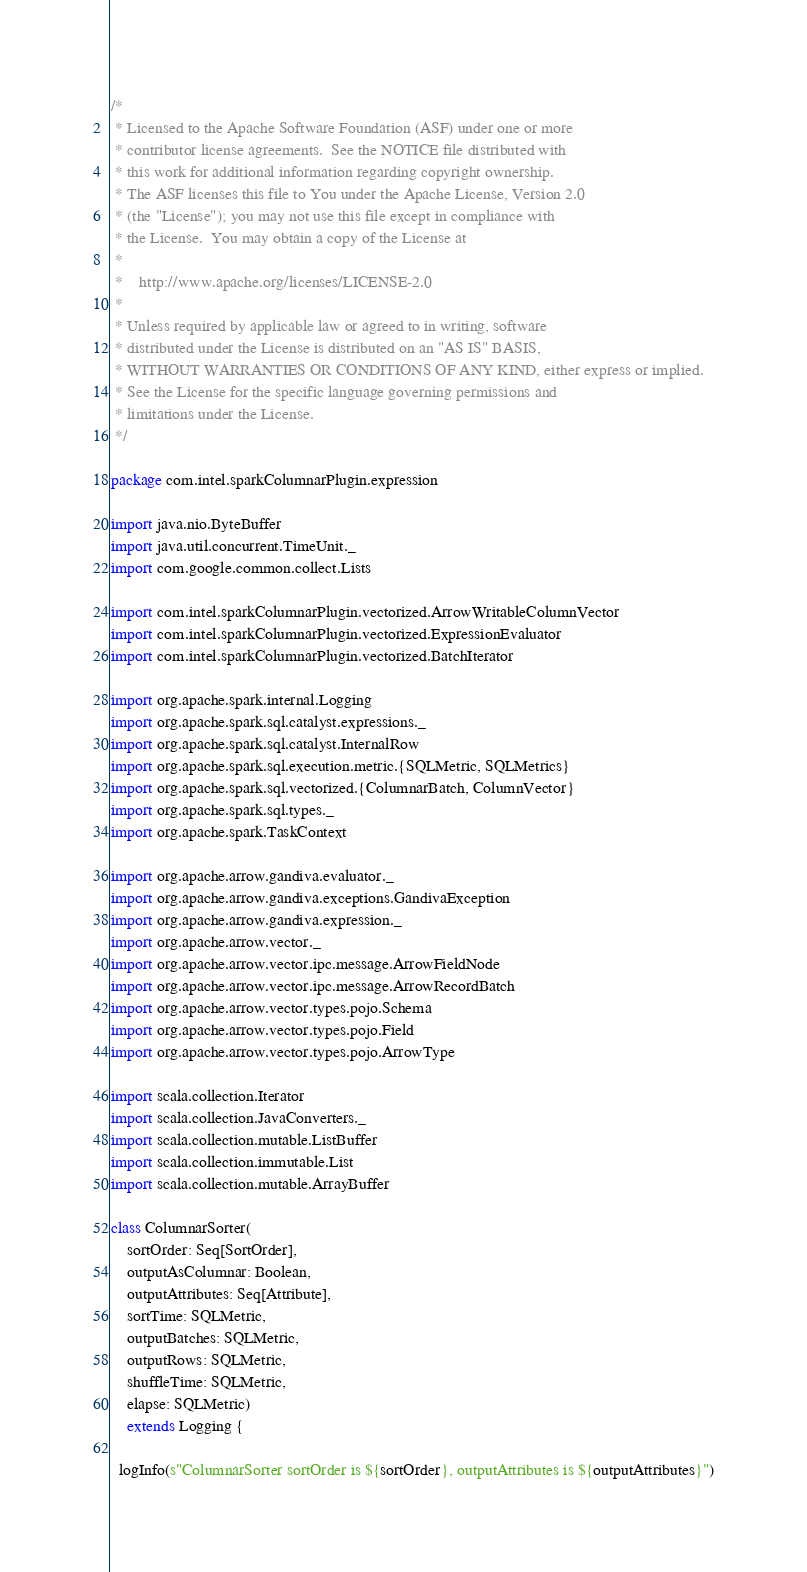<code> <loc_0><loc_0><loc_500><loc_500><_Scala_>/*
 * Licensed to the Apache Software Foundation (ASF) under one or more
 * contributor license agreements.  See the NOTICE file distributed with
 * this work for additional information regarding copyright ownership.
 * The ASF licenses this file to You under the Apache License, Version 2.0
 * (the "License"); you may not use this file except in compliance with
 * the License.  You may obtain a copy of the License at
 *
 *    http://www.apache.org/licenses/LICENSE-2.0
 *
 * Unless required by applicable law or agreed to in writing, software
 * distributed under the License is distributed on an "AS IS" BASIS,
 * WITHOUT WARRANTIES OR CONDITIONS OF ANY KIND, either express or implied.
 * See the License for the specific language governing permissions and
 * limitations under the License.
 */

package com.intel.sparkColumnarPlugin.expression

import java.nio.ByteBuffer
import java.util.concurrent.TimeUnit._
import com.google.common.collect.Lists

import com.intel.sparkColumnarPlugin.vectorized.ArrowWritableColumnVector
import com.intel.sparkColumnarPlugin.vectorized.ExpressionEvaluator
import com.intel.sparkColumnarPlugin.vectorized.BatchIterator

import org.apache.spark.internal.Logging
import org.apache.spark.sql.catalyst.expressions._
import org.apache.spark.sql.catalyst.InternalRow
import org.apache.spark.sql.execution.metric.{SQLMetric, SQLMetrics}
import org.apache.spark.sql.vectorized.{ColumnarBatch, ColumnVector}
import org.apache.spark.sql.types._
import org.apache.spark.TaskContext

import org.apache.arrow.gandiva.evaluator._
import org.apache.arrow.gandiva.exceptions.GandivaException
import org.apache.arrow.gandiva.expression._
import org.apache.arrow.vector._
import org.apache.arrow.vector.ipc.message.ArrowFieldNode
import org.apache.arrow.vector.ipc.message.ArrowRecordBatch
import org.apache.arrow.vector.types.pojo.Schema
import org.apache.arrow.vector.types.pojo.Field
import org.apache.arrow.vector.types.pojo.ArrowType

import scala.collection.Iterator
import scala.collection.JavaConverters._
import scala.collection.mutable.ListBuffer
import scala.collection.immutable.List
import scala.collection.mutable.ArrayBuffer

class ColumnarSorter(
    sortOrder: Seq[SortOrder],
    outputAsColumnar: Boolean,
    outputAttributes: Seq[Attribute],
    sortTime: SQLMetric,
    outputBatches: SQLMetric,
    outputRows: SQLMetric,
    shuffleTime: SQLMetric,
    elapse: SQLMetric)
    extends Logging {

  logInfo(s"ColumnarSorter sortOrder is ${sortOrder}, outputAttributes is ${outputAttributes}")</code> 